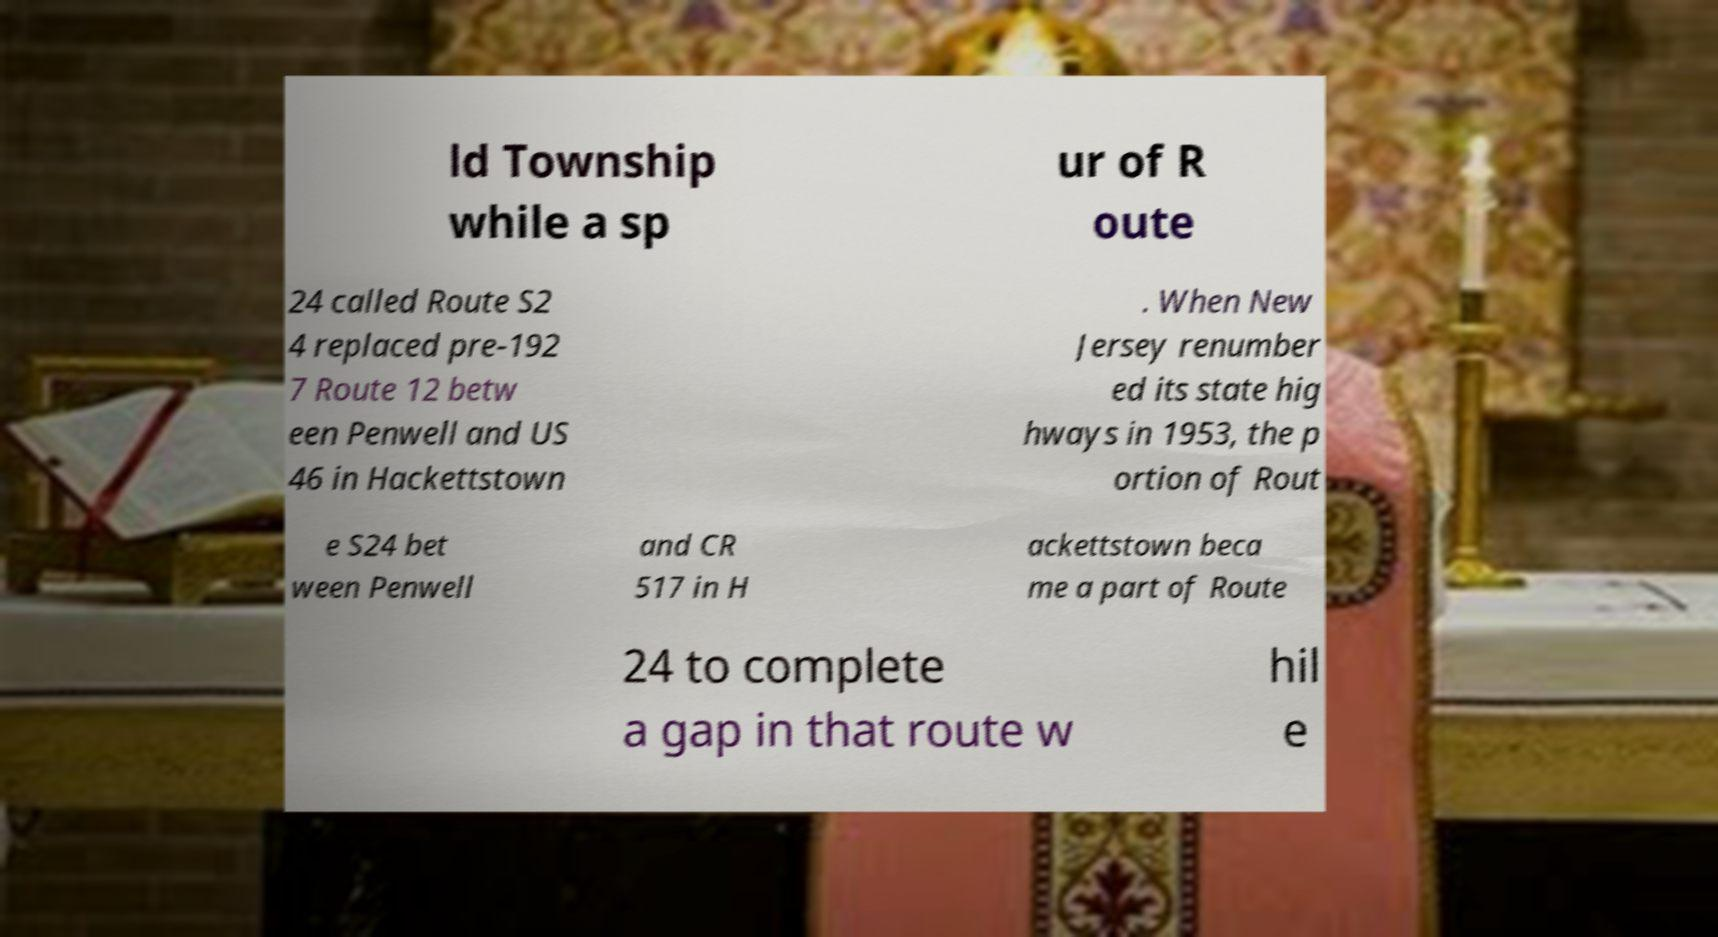I need the written content from this picture converted into text. Can you do that? ld Township while a sp ur of R oute 24 called Route S2 4 replaced pre-192 7 Route 12 betw een Penwell and US 46 in Hackettstown . When New Jersey renumber ed its state hig hways in 1953, the p ortion of Rout e S24 bet ween Penwell and CR 517 in H ackettstown beca me a part of Route 24 to complete a gap in that route w hil e 